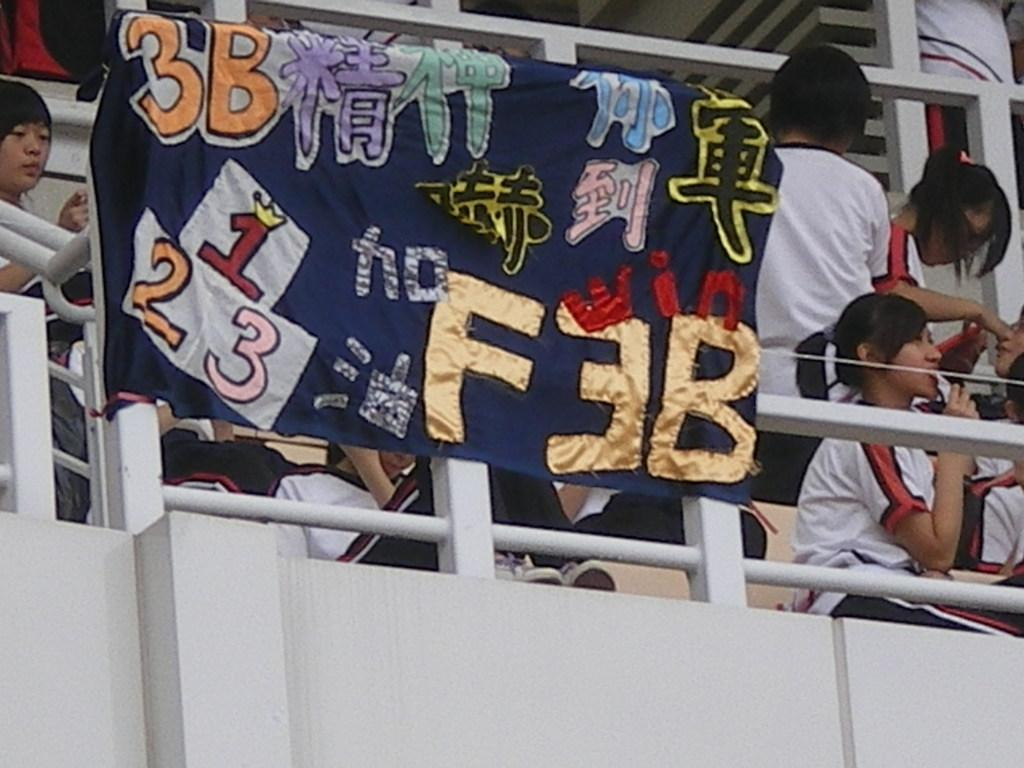What is hanging in the image? There is a banner in the image. What objects are present that might be used to support the banner? There are rods in the image. What is behind the banner? There is a wall in the image. What are the people in the image doing? There is a group of people in the image, and some are sitting while others are standing. What type of food is being served to the rat in the image? There is no rat or food present in the image. What year is depicted in the image? The image does not depict a specific year; it only shows a banner, rods, a wall, and a group of people. 